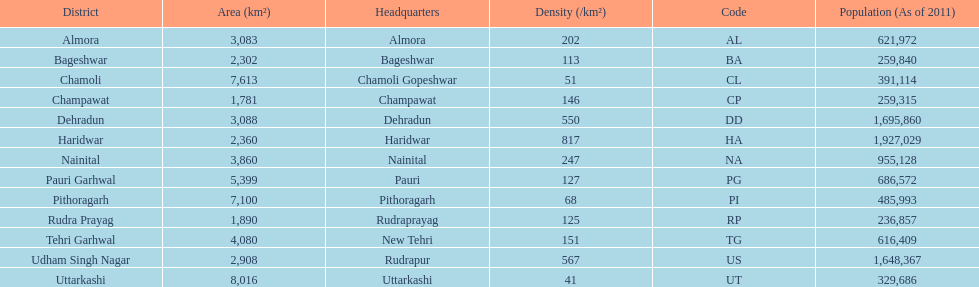How many total districts are there in this area? 13. 